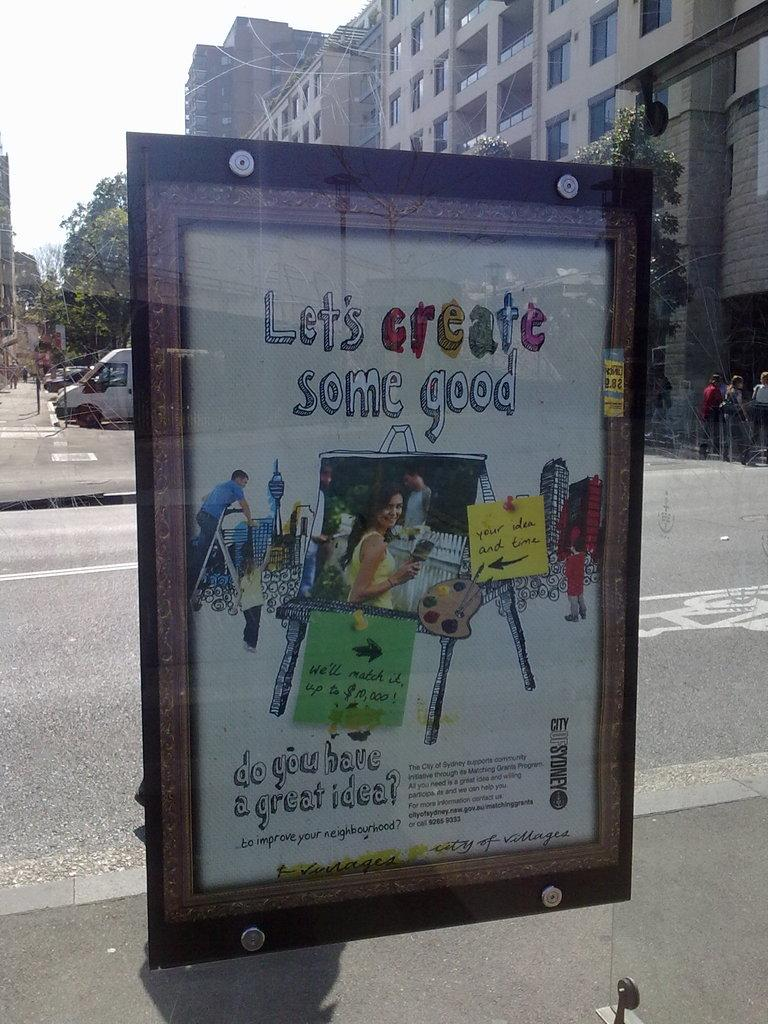<image>
Give a short and clear explanation of the subsequent image. street display that shows people painting and creating things with title let's create some good 